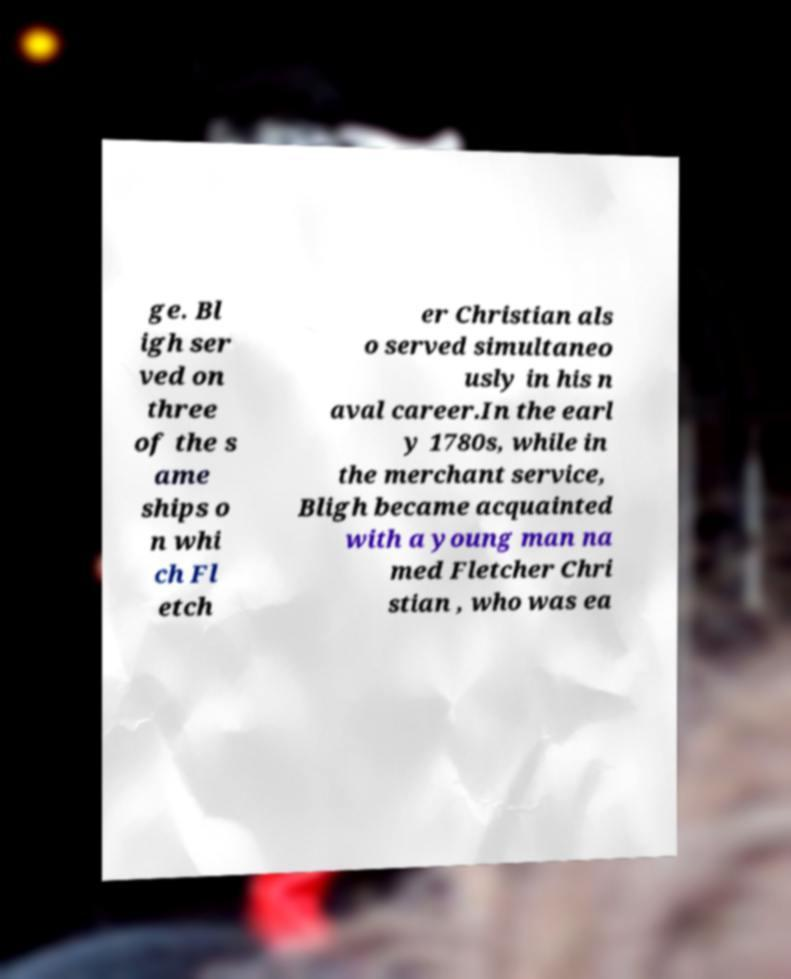Can you accurately transcribe the text from the provided image for me? ge. Bl igh ser ved on three of the s ame ships o n whi ch Fl etch er Christian als o served simultaneo usly in his n aval career.In the earl y 1780s, while in the merchant service, Bligh became acquainted with a young man na med Fletcher Chri stian , who was ea 